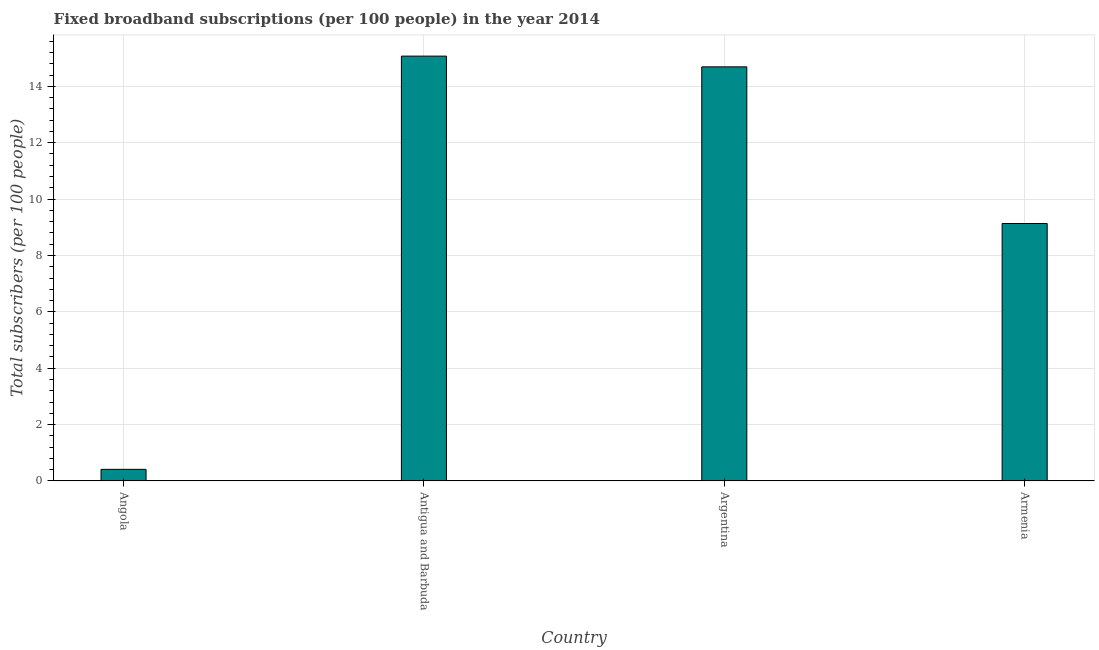What is the title of the graph?
Offer a terse response. Fixed broadband subscriptions (per 100 people) in the year 2014. What is the label or title of the Y-axis?
Ensure brevity in your answer.  Total subscribers (per 100 people). What is the total number of fixed broadband subscriptions in Argentina?
Keep it short and to the point. 14.69. Across all countries, what is the maximum total number of fixed broadband subscriptions?
Your answer should be compact. 15.07. Across all countries, what is the minimum total number of fixed broadband subscriptions?
Offer a terse response. 0.41. In which country was the total number of fixed broadband subscriptions maximum?
Your response must be concise. Antigua and Barbuda. In which country was the total number of fixed broadband subscriptions minimum?
Provide a succinct answer. Angola. What is the sum of the total number of fixed broadband subscriptions?
Give a very brief answer. 39.31. What is the difference between the total number of fixed broadband subscriptions in Angola and Antigua and Barbuda?
Your response must be concise. -14.66. What is the average total number of fixed broadband subscriptions per country?
Offer a terse response. 9.83. What is the median total number of fixed broadband subscriptions?
Give a very brief answer. 11.91. What is the ratio of the total number of fixed broadband subscriptions in Antigua and Barbuda to that in Armenia?
Keep it short and to the point. 1.65. What is the difference between the highest and the second highest total number of fixed broadband subscriptions?
Give a very brief answer. 0.38. Is the sum of the total number of fixed broadband subscriptions in Angola and Argentina greater than the maximum total number of fixed broadband subscriptions across all countries?
Your response must be concise. Yes. What is the difference between the highest and the lowest total number of fixed broadband subscriptions?
Provide a succinct answer. 14.66. In how many countries, is the total number of fixed broadband subscriptions greater than the average total number of fixed broadband subscriptions taken over all countries?
Keep it short and to the point. 2. How many bars are there?
Make the answer very short. 4. Are all the bars in the graph horizontal?
Provide a succinct answer. No. How many countries are there in the graph?
Offer a very short reply. 4. What is the difference between two consecutive major ticks on the Y-axis?
Provide a succinct answer. 2. What is the Total subscribers (per 100 people) of Angola?
Offer a very short reply. 0.41. What is the Total subscribers (per 100 people) in Antigua and Barbuda?
Give a very brief answer. 15.07. What is the Total subscribers (per 100 people) in Argentina?
Keep it short and to the point. 14.69. What is the Total subscribers (per 100 people) in Armenia?
Offer a terse response. 9.13. What is the difference between the Total subscribers (per 100 people) in Angola and Antigua and Barbuda?
Provide a short and direct response. -14.66. What is the difference between the Total subscribers (per 100 people) in Angola and Argentina?
Keep it short and to the point. -14.28. What is the difference between the Total subscribers (per 100 people) in Angola and Armenia?
Offer a very short reply. -8.72. What is the difference between the Total subscribers (per 100 people) in Antigua and Barbuda and Argentina?
Make the answer very short. 0.38. What is the difference between the Total subscribers (per 100 people) in Antigua and Barbuda and Armenia?
Make the answer very short. 5.94. What is the difference between the Total subscribers (per 100 people) in Argentina and Armenia?
Ensure brevity in your answer.  5.56. What is the ratio of the Total subscribers (per 100 people) in Angola to that in Antigua and Barbuda?
Keep it short and to the point. 0.03. What is the ratio of the Total subscribers (per 100 people) in Angola to that in Argentina?
Your response must be concise. 0.03. What is the ratio of the Total subscribers (per 100 people) in Angola to that in Armenia?
Provide a succinct answer. 0.04. What is the ratio of the Total subscribers (per 100 people) in Antigua and Barbuda to that in Armenia?
Give a very brief answer. 1.65. What is the ratio of the Total subscribers (per 100 people) in Argentina to that in Armenia?
Your response must be concise. 1.61. 